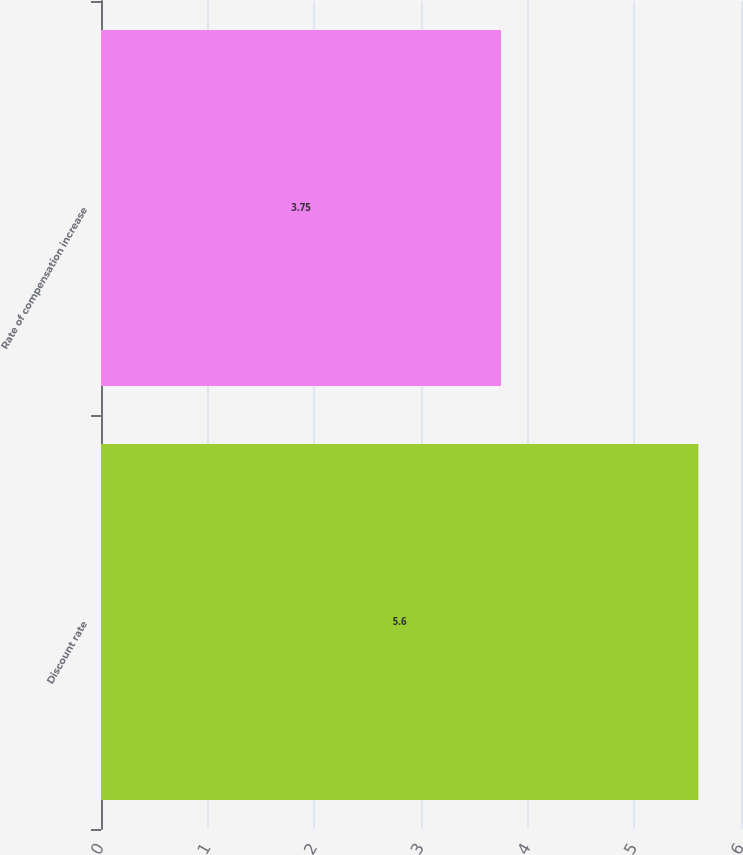Convert chart to OTSL. <chart><loc_0><loc_0><loc_500><loc_500><bar_chart><fcel>Discount rate<fcel>Rate of compensation increase<nl><fcel>5.6<fcel>3.75<nl></chart> 